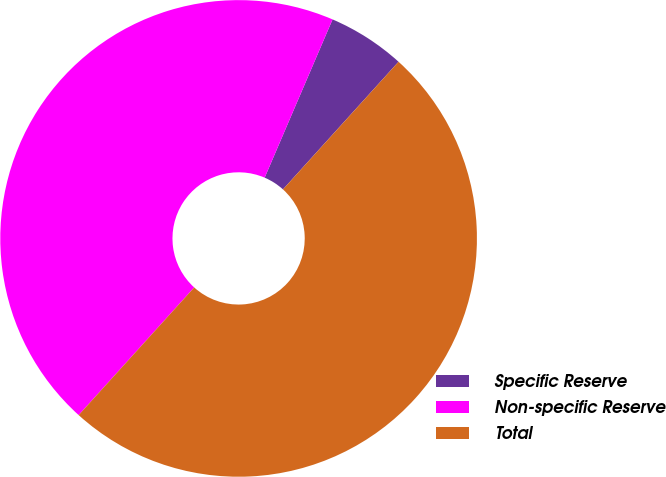Convert chart. <chart><loc_0><loc_0><loc_500><loc_500><pie_chart><fcel>Specific Reserve<fcel>Non-specific Reserve<fcel>Total<nl><fcel>5.26%<fcel>44.74%<fcel>50.0%<nl></chart> 